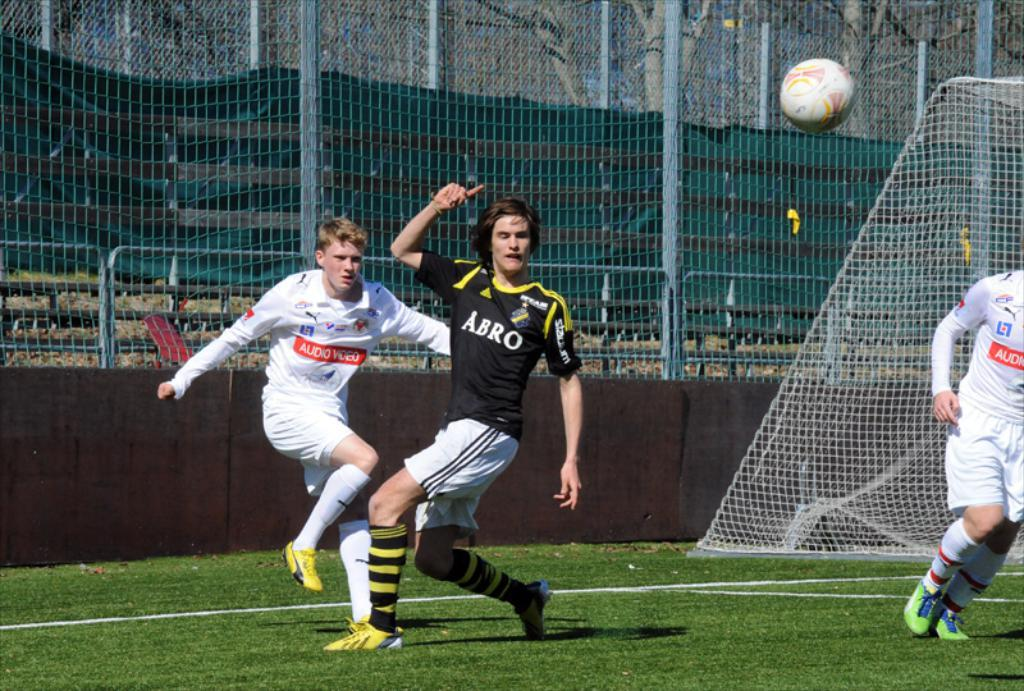Where is the image taken? The image is taken on the ground. How many people are in the image? There are three people in the image. What are the people doing in the image? The people are playing a game. What is behind the people in the image? There is a net behind the people. What object is involved in the game being played? There is a ball in the image. What type of natural scenery is visible in the image? Trees are visible at the top of the image. Where is the faucet located in the image? There is no faucet present in the image. What channel are the people watching while playing the game? The image does not show any television or channel; the people are playing a game outdoors. 